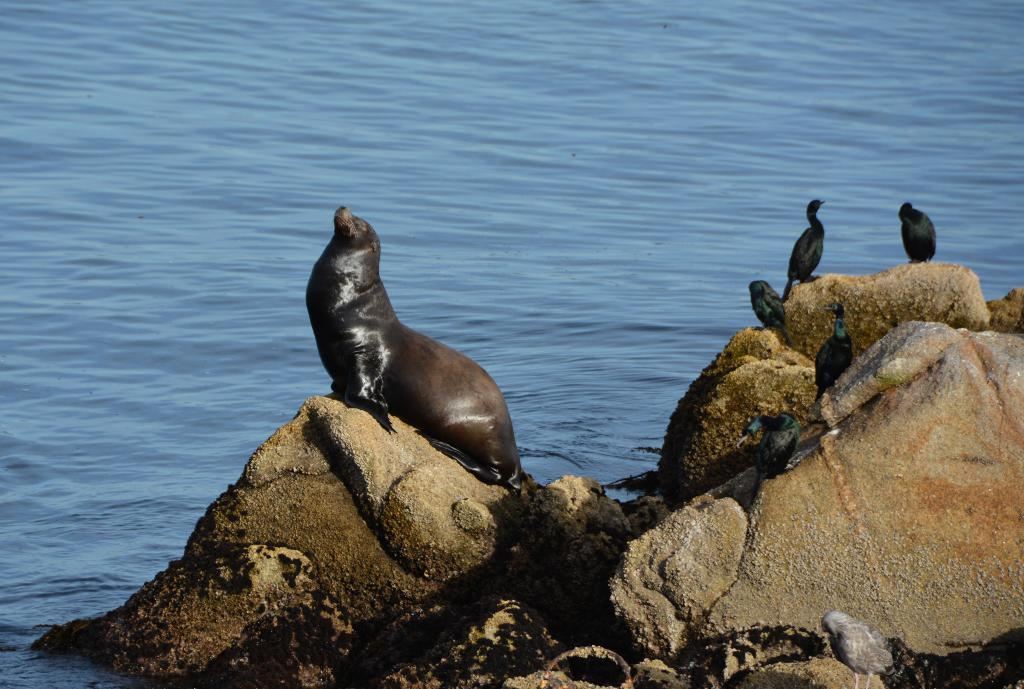What type of animal can be seen in the image? There is a seal in the image. What other animals are present in the image? There are birds in the image. Where are the seal and birds located? The seal and birds are on rocks. What is the location of the rocks in the image? The rocks are at the water. What type of dirt can be seen in the image? There is no dirt present in the image; it features a seal and birds on rocks at the water. What type of eggnog is being served to the birds in the image? There is no eggnog present in the image; it features a seal and birds on rocks at the water. 